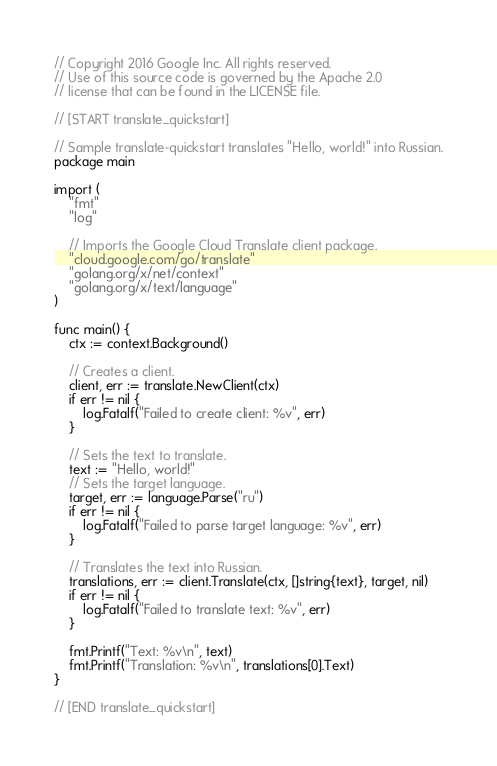Convert code to text. <code><loc_0><loc_0><loc_500><loc_500><_Go_>// Copyright 2016 Google Inc. All rights reserved.
// Use of this source code is governed by the Apache 2.0
// license that can be found in the LICENSE file.

// [START translate_quickstart]

// Sample translate-quickstart translates "Hello, world!" into Russian.
package main

import (
	"fmt"
	"log"

	// Imports the Google Cloud Translate client package.
	"cloud.google.com/go/translate"
	"golang.org/x/net/context"
	"golang.org/x/text/language"
)

func main() {
	ctx := context.Background()

	// Creates a client.
	client, err := translate.NewClient(ctx)
	if err != nil {
		log.Fatalf("Failed to create client: %v", err)
	}

	// Sets the text to translate.
	text := "Hello, world!"
	// Sets the target language.
	target, err := language.Parse("ru")
	if err != nil {
		log.Fatalf("Failed to parse target language: %v", err)
	}

	// Translates the text into Russian.
	translations, err := client.Translate(ctx, []string{text}, target, nil)
	if err != nil {
		log.Fatalf("Failed to translate text: %v", err)
	}

	fmt.Printf("Text: %v\n", text)
	fmt.Printf("Translation: %v\n", translations[0].Text)
}

// [END translate_quickstart]
</code> 